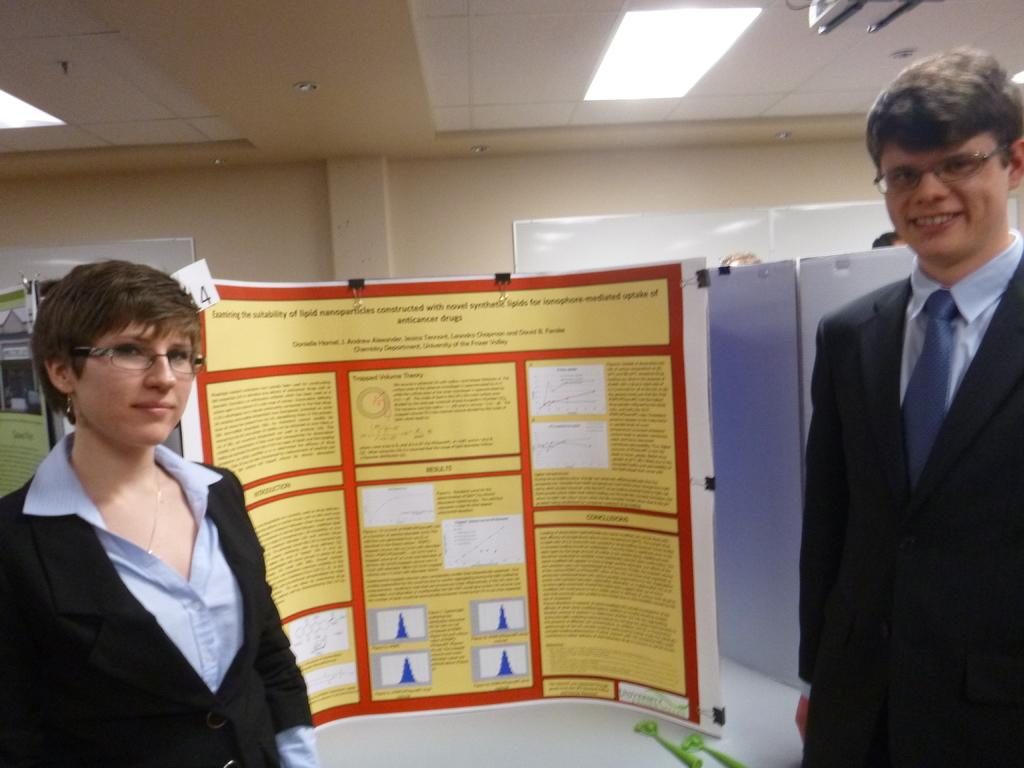What can be seen in the image involving people? There are people standing in the image. What is the object with writing on it in the image? There is a banner sheet in the image. Where is the banner sheet located? The banner sheet is placed on a table. What type of pump can be seen in the image? There is no pump present in the image. What time of day is it in the image, given the presence of morning light? The time of day is not mentioned or indicated in the image, so it cannot be determined. 